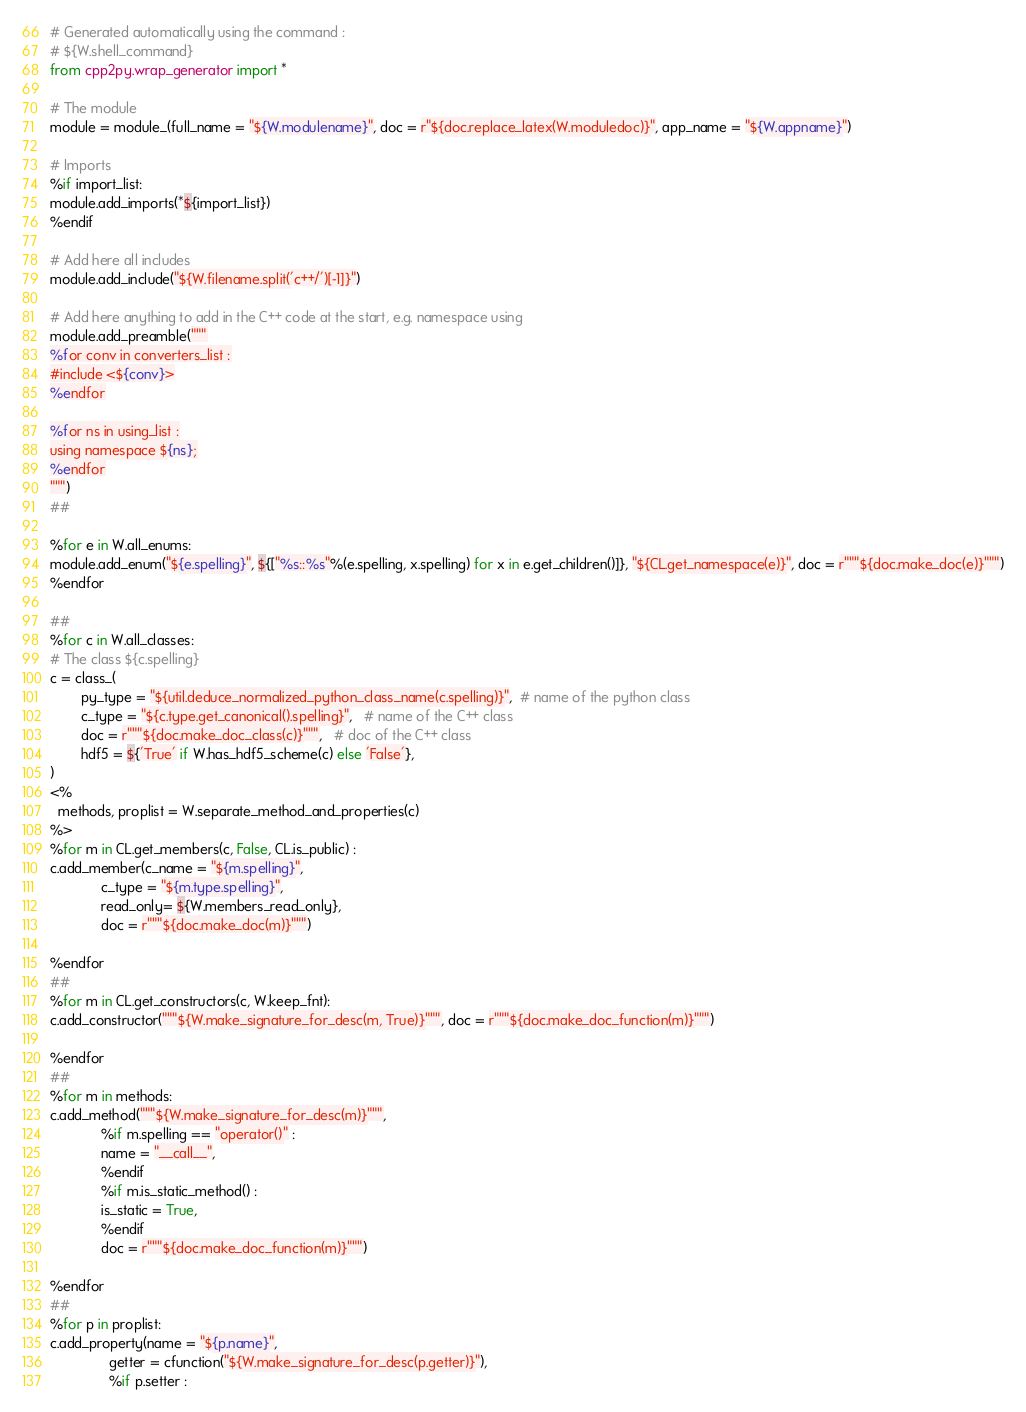<code> <loc_0><loc_0><loc_500><loc_500><_Python_># Generated automatically using the command :
# ${W.shell_command}
from cpp2py.wrap_generator import *

# The module
module = module_(full_name = "${W.modulename}", doc = r"${doc.replace_latex(W.moduledoc)}", app_name = "${W.appname}")

# Imports
%if import_list:
module.add_imports(*${import_list})
%endif

# Add here all includes 
module.add_include("${W.filename.split('c++/')[-1]}")

# Add here anything to add in the C++ code at the start, e.g. namespace using
module.add_preamble("""
%for conv in converters_list :
#include <${conv}>
%endfor

%for ns in using_list :
using namespace ${ns};
%endfor
""")
##

%for e in W.all_enums:
module.add_enum("${e.spelling}", ${["%s::%s"%(e.spelling, x.spelling) for x in e.get_children()]}, "${CL.get_namespace(e)}", doc = r"""${doc.make_doc(e)}""")
%endfor

##
%for c in W.all_classes:
# The class ${c.spelling}
c = class_(
        py_type = "${util.deduce_normalized_python_class_name(c.spelling)}",  # name of the python class
        c_type = "${c.type.get_canonical().spelling}",   # name of the C++ class
        doc = r"""${doc.make_doc_class(c)}""",   # doc of the C++ class
        hdf5 = ${'True' if W.has_hdf5_scheme(c) else 'False'},
)
<%
  methods, proplist = W.separate_method_and_properties(c)
%>
%for m in CL.get_members(c, False, CL.is_public) :
c.add_member(c_name = "${m.spelling}",
             c_type = "${m.type.spelling}",
             read_only= ${W.members_read_only},
             doc = r"""${doc.make_doc(m)}""")

%endfor
##
%for m in CL.get_constructors(c, W.keep_fnt):
c.add_constructor("""${W.make_signature_for_desc(m, True)}""", doc = r"""${doc.make_doc_function(m)}""")

%endfor
##
%for m in methods:
c.add_method("""${W.make_signature_for_desc(m)}""",
             %if m.spelling == "operator()" :
             name = "__call__",
             %endif
             %if m.is_static_method() :
             is_static = True,
             %endif
             doc = r"""${doc.make_doc_function(m)}""")

%endfor
##
%for p in proplist:
c.add_property(name = "${p.name}",
               getter = cfunction("${W.make_signature_for_desc(p.getter)}"),
               %if p.setter :</code> 